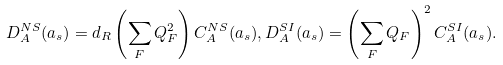Convert formula to latex. <formula><loc_0><loc_0><loc_500><loc_500>D _ { A } ^ { N S } ( a _ { s } ) = d _ { R } \left ( \sum _ { F } Q _ { F } ^ { 2 } \right ) C _ { A } ^ { N S } ( a _ { s } ) , D _ { A } ^ { S I } ( a _ { s } ) = \left ( \sum _ { F } Q _ { F } \right ) ^ { 2 } C _ { A } ^ { S I } ( a _ { s } ) .</formula> 